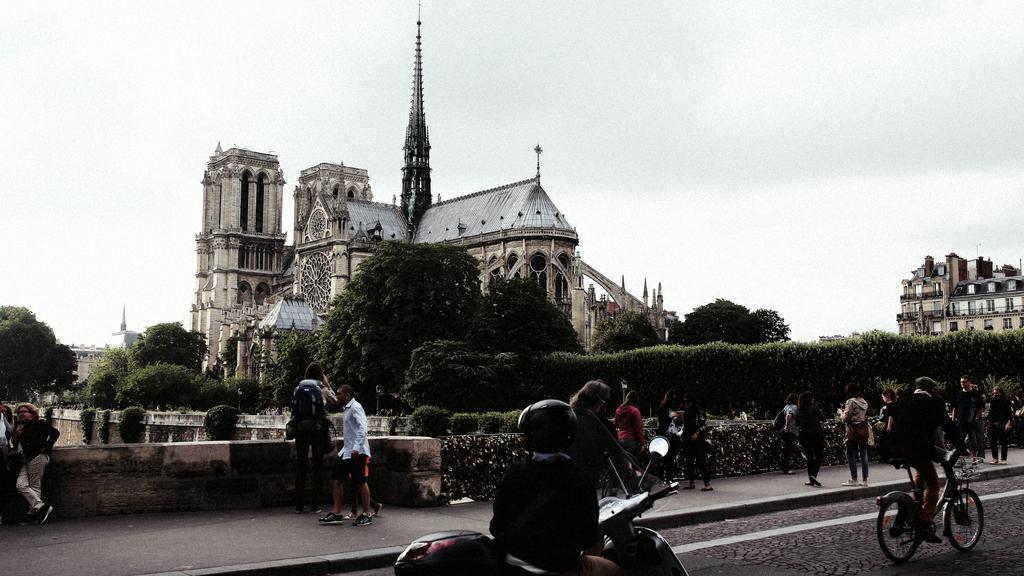In one or two sentences, can you explain what this image depicts? In the image we can see there are people who are travelling on the road, people are standing on the footpath and at the back there are lot of trees and there is a building and there is a clear sky. 